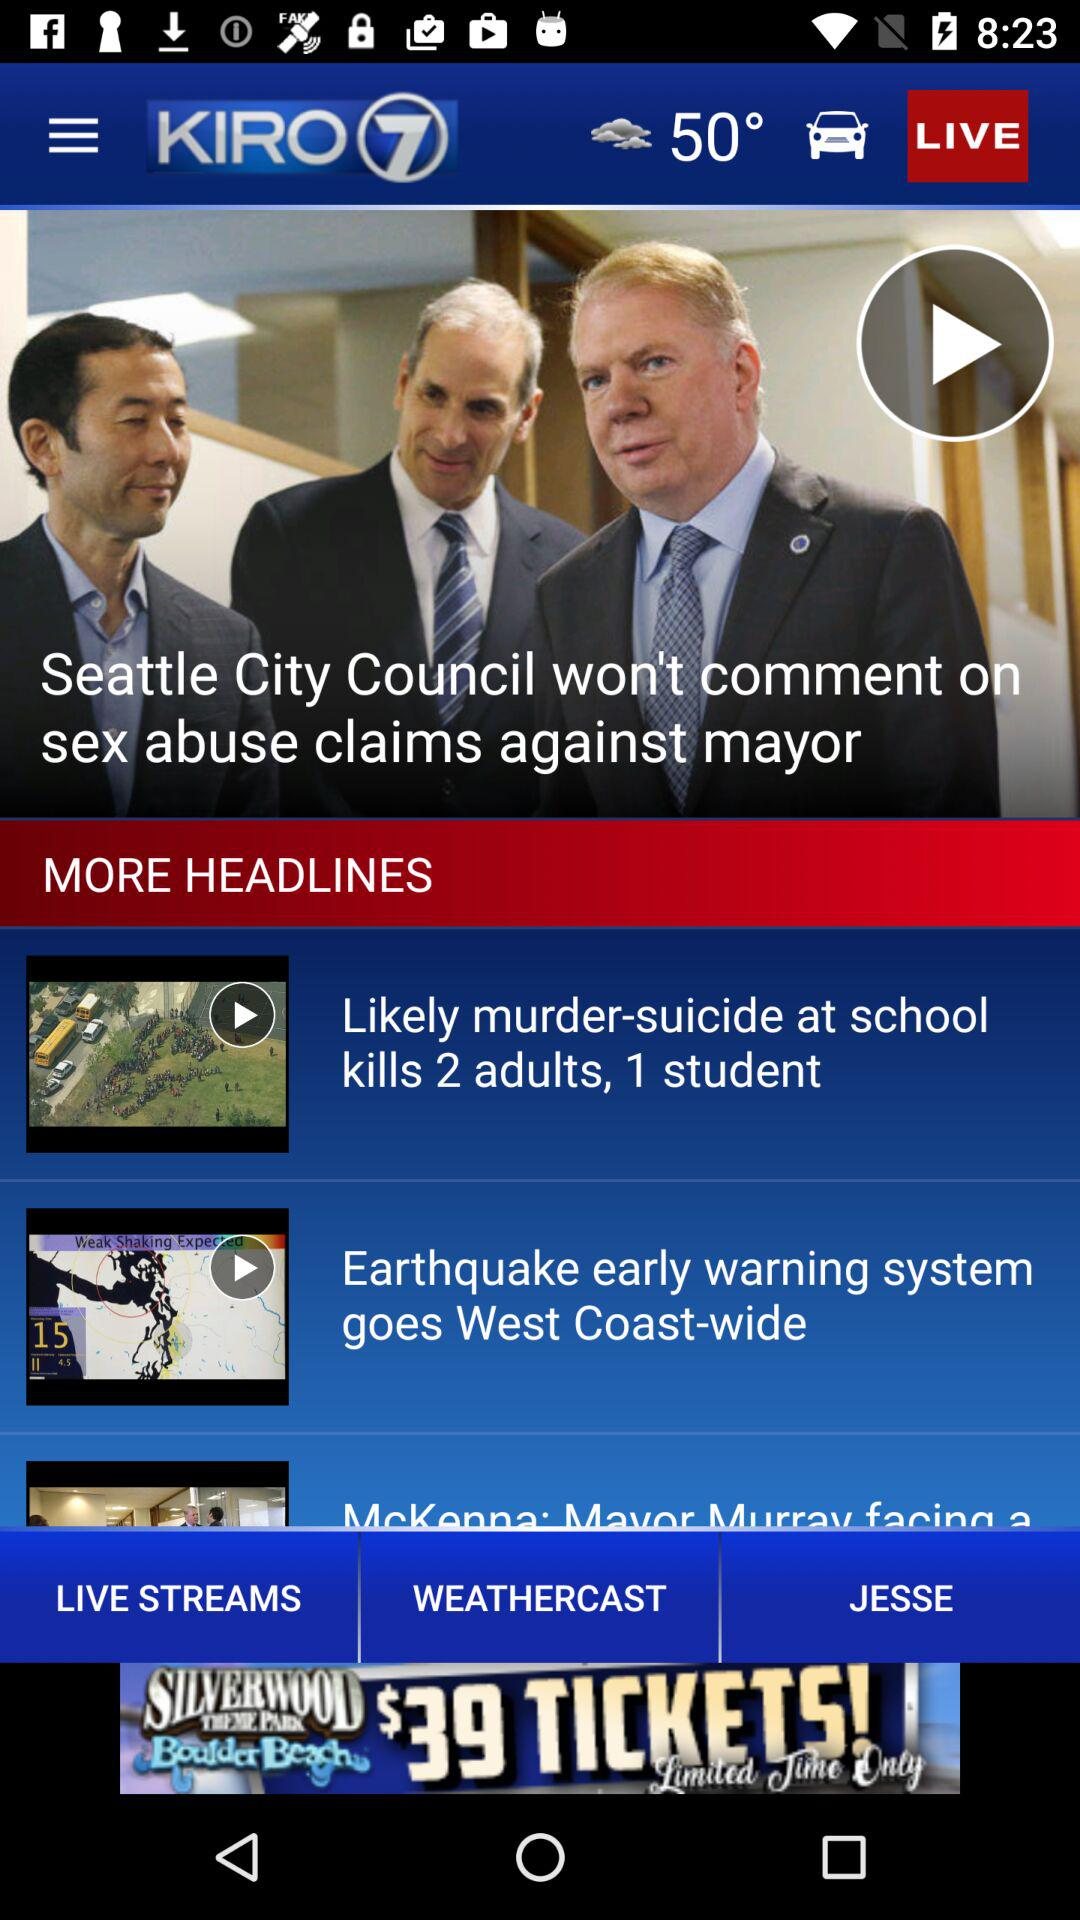How many degrees Fahrenheit is the current temperature?
Answer the question using a single word or phrase. 50° 